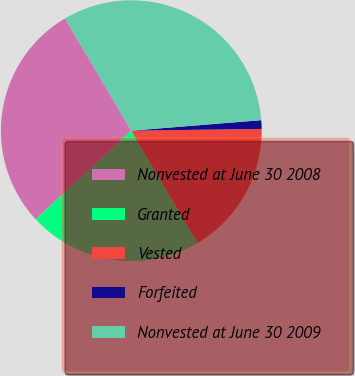Convert chart. <chart><loc_0><loc_0><loc_500><loc_500><pie_chart><fcel>Nonvested at June 30 2008<fcel>Granted<fcel>Vested<fcel>Forfeited<fcel>Nonvested at June 30 2009<nl><fcel>28.41%<fcel>21.59%<fcel>16.73%<fcel>1.07%<fcel>32.2%<nl></chart> 